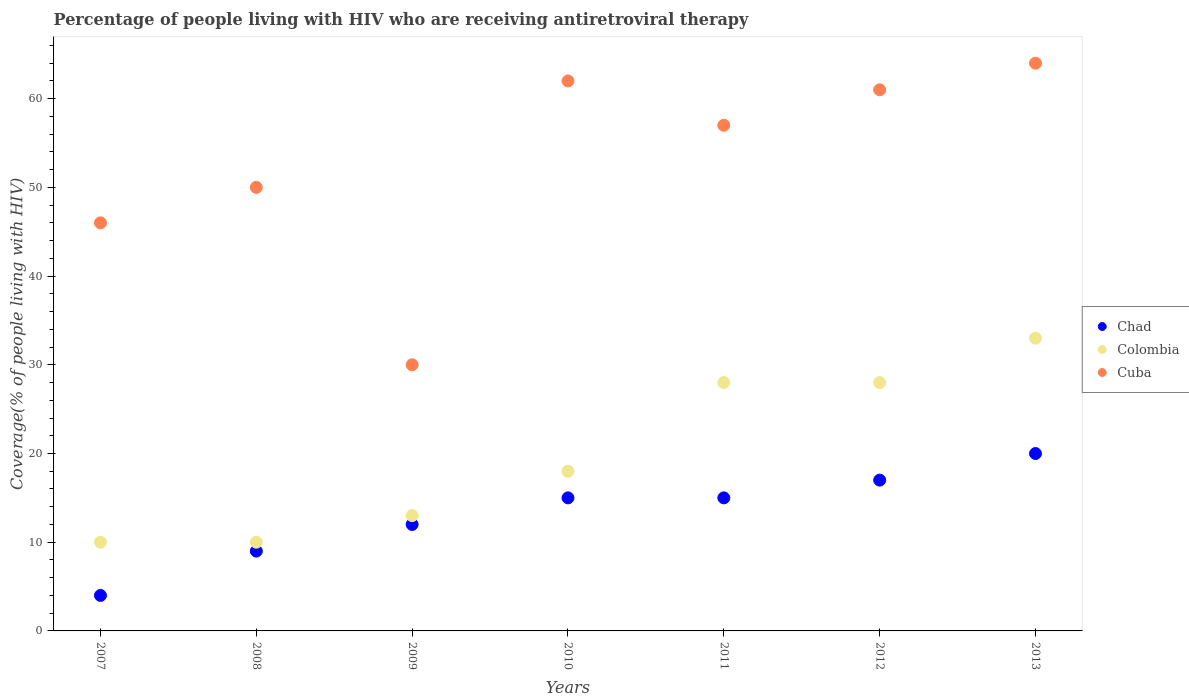How many different coloured dotlines are there?
Make the answer very short. 3. What is the percentage of the HIV infected people who are receiving antiretroviral therapy in Cuba in 2011?
Your response must be concise. 57. Across all years, what is the maximum percentage of the HIV infected people who are receiving antiretroviral therapy in Colombia?
Ensure brevity in your answer.  33. Across all years, what is the minimum percentage of the HIV infected people who are receiving antiretroviral therapy in Cuba?
Offer a terse response. 30. In which year was the percentage of the HIV infected people who are receiving antiretroviral therapy in Colombia maximum?
Keep it short and to the point. 2013. In which year was the percentage of the HIV infected people who are receiving antiretroviral therapy in Cuba minimum?
Provide a short and direct response. 2009. What is the total percentage of the HIV infected people who are receiving antiretroviral therapy in Cuba in the graph?
Provide a short and direct response. 370. What is the difference between the percentage of the HIV infected people who are receiving antiretroviral therapy in Chad in 2007 and that in 2012?
Offer a terse response. -13. What is the difference between the percentage of the HIV infected people who are receiving antiretroviral therapy in Chad in 2009 and the percentage of the HIV infected people who are receiving antiretroviral therapy in Colombia in 2007?
Your answer should be compact. 2. What is the average percentage of the HIV infected people who are receiving antiretroviral therapy in Chad per year?
Offer a terse response. 13.14. In the year 2011, what is the difference between the percentage of the HIV infected people who are receiving antiretroviral therapy in Colombia and percentage of the HIV infected people who are receiving antiretroviral therapy in Chad?
Make the answer very short. 13. What is the ratio of the percentage of the HIV infected people who are receiving antiretroviral therapy in Colombia in 2007 to that in 2012?
Provide a short and direct response. 0.36. Is the percentage of the HIV infected people who are receiving antiretroviral therapy in Chad in 2011 less than that in 2013?
Provide a short and direct response. Yes. What is the difference between the highest and the lowest percentage of the HIV infected people who are receiving antiretroviral therapy in Cuba?
Offer a terse response. 34. In how many years, is the percentage of the HIV infected people who are receiving antiretroviral therapy in Cuba greater than the average percentage of the HIV infected people who are receiving antiretroviral therapy in Cuba taken over all years?
Your answer should be compact. 4. Is it the case that in every year, the sum of the percentage of the HIV infected people who are receiving antiretroviral therapy in Chad and percentage of the HIV infected people who are receiving antiretroviral therapy in Colombia  is greater than the percentage of the HIV infected people who are receiving antiretroviral therapy in Cuba?
Provide a succinct answer. No. Is the percentage of the HIV infected people who are receiving antiretroviral therapy in Chad strictly greater than the percentage of the HIV infected people who are receiving antiretroviral therapy in Cuba over the years?
Keep it short and to the point. No. Is the percentage of the HIV infected people who are receiving antiretroviral therapy in Colombia strictly less than the percentage of the HIV infected people who are receiving antiretroviral therapy in Cuba over the years?
Offer a terse response. Yes. Does the graph contain grids?
Offer a terse response. No. Where does the legend appear in the graph?
Provide a short and direct response. Center right. How are the legend labels stacked?
Make the answer very short. Vertical. What is the title of the graph?
Provide a succinct answer. Percentage of people living with HIV who are receiving antiretroviral therapy. Does "Panama" appear as one of the legend labels in the graph?
Keep it short and to the point. No. What is the label or title of the X-axis?
Keep it short and to the point. Years. What is the label or title of the Y-axis?
Make the answer very short. Coverage(% of people living with HIV). What is the Coverage(% of people living with HIV) of Cuba in 2007?
Your answer should be compact. 46. What is the Coverage(% of people living with HIV) in Colombia in 2008?
Your answer should be compact. 10. What is the Coverage(% of people living with HIV) of Colombia in 2009?
Keep it short and to the point. 13. What is the Coverage(% of people living with HIV) in Cuba in 2009?
Your response must be concise. 30. What is the Coverage(% of people living with HIV) in Chad in 2010?
Your answer should be compact. 15. What is the Coverage(% of people living with HIV) in Cuba in 2010?
Offer a very short reply. 62. What is the Coverage(% of people living with HIV) of Chad in 2011?
Provide a short and direct response. 15. What is the Coverage(% of people living with HIV) in Colombia in 2011?
Ensure brevity in your answer.  28. What is the Coverage(% of people living with HIV) in Cuba in 2011?
Offer a very short reply. 57. What is the Coverage(% of people living with HIV) in Cuba in 2012?
Keep it short and to the point. 61. What is the Coverage(% of people living with HIV) of Chad in 2013?
Provide a short and direct response. 20. Across all years, what is the maximum Coverage(% of people living with HIV) in Chad?
Your answer should be compact. 20. Across all years, what is the minimum Coverage(% of people living with HIV) of Chad?
Provide a succinct answer. 4. Across all years, what is the minimum Coverage(% of people living with HIV) in Cuba?
Offer a very short reply. 30. What is the total Coverage(% of people living with HIV) of Chad in the graph?
Keep it short and to the point. 92. What is the total Coverage(% of people living with HIV) of Colombia in the graph?
Keep it short and to the point. 140. What is the total Coverage(% of people living with HIV) in Cuba in the graph?
Ensure brevity in your answer.  370. What is the difference between the Coverage(% of people living with HIV) in Chad in 2007 and that in 2008?
Ensure brevity in your answer.  -5. What is the difference between the Coverage(% of people living with HIV) of Colombia in 2007 and that in 2008?
Offer a terse response. 0. What is the difference between the Coverage(% of people living with HIV) in Cuba in 2007 and that in 2008?
Offer a terse response. -4. What is the difference between the Coverage(% of people living with HIV) in Colombia in 2007 and that in 2009?
Make the answer very short. -3. What is the difference between the Coverage(% of people living with HIV) in Cuba in 2007 and that in 2010?
Make the answer very short. -16. What is the difference between the Coverage(% of people living with HIV) in Colombia in 2007 and that in 2011?
Give a very brief answer. -18. What is the difference between the Coverage(% of people living with HIV) of Chad in 2007 and that in 2012?
Provide a succinct answer. -13. What is the difference between the Coverage(% of people living with HIV) of Cuba in 2007 and that in 2012?
Provide a short and direct response. -15. What is the difference between the Coverage(% of people living with HIV) of Chad in 2007 and that in 2013?
Give a very brief answer. -16. What is the difference between the Coverage(% of people living with HIV) of Chad in 2008 and that in 2009?
Offer a very short reply. -3. What is the difference between the Coverage(% of people living with HIV) of Chad in 2008 and that in 2010?
Ensure brevity in your answer.  -6. What is the difference between the Coverage(% of people living with HIV) in Chad in 2008 and that in 2011?
Make the answer very short. -6. What is the difference between the Coverage(% of people living with HIV) in Chad in 2008 and that in 2012?
Make the answer very short. -8. What is the difference between the Coverage(% of people living with HIV) in Colombia in 2008 and that in 2012?
Provide a succinct answer. -18. What is the difference between the Coverage(% of people living with HIV) in Cuba in 2008 and that in 2012?
Your answer should be very brief. -11. What is the difference between the Coverage(% of people living with HIV) of Colombia in 2008 and that in 2013?
Ensure brevity in your answer.  -23. What is the difference between the Coverage(% of people living with HIV) of Chad in 2009 and that in 2010?
Provide a succinct answer. -3. What is the difference between the Coverage(% of people living with HIV) in Cuba in 2009 and that in 2010?
Ensure brevity in your answer.  -32. What is the difference between the Coverage(% of people living with HIV) in Chad in 2009 and that in 2011?
Give a very brief answer. -3. What is the difference between the Coverage(% of people living with HIV) in Chad in 2009 and that in 2012?
Make the answer very short. -5. What is the difference between the Coverage(% of people living with HIV) of Cuba in 2009 and that in 2012?
Keep it short and to the point. -31. What is the difference between the Coverage(% of people living with HIV) in Chad in 2009 and that in 2013?
Ensure brevity in your answer.  -8. What is the difference between the Coverage(% of people living with HIV) in Cuba in 2009 and that in 2013?
Provide a succinct answer. -34. What is the difference between the Coverage(% of people living with HIV) of Chad in 2010 and that in 2011?
Offer a very short reply. 0. What is the difference between the Coverage(% of people living with HIV) of Cuba in 2010 and that in 2011?
Keep it short and to the point. 5. What is the difference between the Coverage(% of people living with HIV) of Chad in 2010 and that in 2012?
Ensure brevity in your answer.  -2. What is the difference between the Coverage(% of people living with HIV) in Colombia in 2010 and that in 2012?
Offer a terse response. -10. What is the difference between the Coverage(% of people living with HIV) in Chad in 2010 and that in 2013?
Ensure brevity in your answer.  -5. What is the difference between the Coverage(% of people living with HIV) of Colombia in 2010 and that in 2013?
Offer a terse response. -15. What is the difference between the Coverage(% of people living with HIV) of Cuba in 2010 and that in 2013?
Keep it short and to the point. -2. What is the difference between the Coverage(% of people living with HIV) of Cuba in 2011 and that in 2013?
Your response must be concise. -7. What is the difference between the Coverage(% of people living with HIV) in Chad in 2012 and that in 2013?
Offer a terse response. -3. What is the difference between the Coverage(% of people living with HIV) of Colombia in 2012 and that in 2013?
Provide a short and direct response. -5. What is the difference between the Coverage(% of people living with HIV) of Chad in 2007 and the Coverage(% of people living with HIV) of Cuba in 2008?
Ensure brevity in your answer.  -46. What is the difference between the Coverage(% of people living with HIV) of Colombia in 2007 and the Coverage(% of people living with HIV) of Cuba in 2008?
Ensure brevity in your answer.  -40. What is the difference between the Coverage(% of people living with HIV) in Colombia in 2007 and the Coverage(% of people living with HIV) in Cuba in 2009?
Provide a short and direct response. -20. What is the difference between the Coverage(% of people living with HIV) of Chad in 2007 and the Coverage(% of people living with HIV) of Cuba in 2010?
Give a very brief answer. -58. What is the difference between the Coverage(% of people living with HIV) of Colombia in 2007 and the Coverage(% of people living with HIV) of Cuba in 2010?
Your answer should be very brief. -52. What is the difference between the Coverage(% of people living with HIV) of Chad in 2007 and the Coverage(% of people living with HIV) of Cuba in 2011?
Your answer should be compact. -53. What is the difference between the Coverage(% of people living with HIV) of Colombia in 2007 and the Coverage(% of people living with HIV) of Cuba in 2011?
Give a very brief answer. -47. What is the difference between the Coverage(% of people living with HIV) of Chad in 2007 and the Coverage(% of people living with HIV) of Cuba in 2012?
Provide a short and direct response. -57. What is the difference between the Coverage(% of people living with HIV) in Colombia in 2007 and the Coverage(% of people living with HIV) in Cuba in 2012?
Offer a very short reply. -51. What is the difference between the Coverage(% of people living with HIV) in Chad in 2007 and the Coverage(% of people living with HIV) in Colombia in 2013?
Give a very brief answer. -29. What is the difference between the Coverage(% of people living with HIV) of Chad in 2007 and the Coverage(% of people living with HIV) of Cuba in 2013?
Provide a short and direct response. -60. What is the difference between the Coverage(% of people living with HIV) in Colombia in 2007 and the Coverage(% of people living with HIV) in Cuba in 2013?
Provide a succinct answer. -54. What is the difference between the Coverage(% of people living with HIV) in Chad in 2008 and the Coverage(% of people living with HIV) in Colombia in 2009?
Give a very brief answer. -4. What is the difference between the Coverage(% of people living with HIV) in Chad in 2008 and the Coverage(% of people living with HIV) in Cuba in 2009?
Give a very brief answer. -21. What is the difference between the Coverage(% of people living with HIV) of Colombia in 2008 and the Coverage(% of people living with HIV) of Cuba in 2009?
Ensure brevity in your answer.  -20. What is the difference between the Coverage(% of people living with HIV) of Chad in 2008 and the Coverage(% of people living with HIV) of Colombia in 2010?
Your answer should be compact. -9. What is the difference between the Coverage(% of people living with HIV) of Chad in 2008 and the Coverage(% of people living with HIV) of Cuba in 2010?
Offer a terse response. -53. What is the difference between the Coverage(% of people living with HIV) in Colombia in 2008 and the Coverage(% of people living with HIV) in Cuba in 2010?
Your answer should be compact. -52. What is the difference between the Coverage(% of people living with HIV) in Chad in 2008 and the Coverage(% of people living with HIV) in Colombia in 2011?
Provide a succinct answer. -19. What is the difference between the Coverage(% of people living with HIV) of Chad in 2008 and the Coverage(% of people living with HIV) of Cuba in 2011?
Your response must be concise. -48. What is the difference between the Coverage(% of people living with HIV) in Colombia in 2008 and the Coverage(% of people living with HIV) in Cuba in 2011?
Offer a very short reply. -47. What is the difference between the Coverage(% of people living with HIV) in Chad in 2008 and the Coverage(% of people living with HIV) in Colombia in 2012?
Give a very brief answer. -19. What is the difference between the Coverage(% of people living with HIV) in Chad in 2008 and the Coverage(% of people living with HIV) in Cuba in 2012?
Ensure brevity in your answer.  -52. What is the difference between the Coverage(% of people living with HIV) of Colombia in 2008 and the Coverage(% of people living with HIV) of Cuba in 2012?
Give a very brief answer. -51. What is the difference between the Coverage(% of people living with HIV) in Chad in 2008 and the Coverage(% of people living with HIV) in Cuba in 2013?
Provide a succinct answer. -55. What is the difference between the Coverage(% of people living with HIV) of Colombia in 2008 and the Coverage(% of people living with HIV) of Cuba in 2013?
Your answer should be compact. -54. What is the difference between the Coverage(% of people living with HIV) in Chad in 2009 and the Coverage(% of people living with HIV) in Cuba in 2010?
Offer a terse response. -50. What is the difference between the Coverage(% of people living with HIV) in Colombia in 2009 and the Coverage(% of people living with HIV) in Cuba in 2010?
Your answer should be very brief. -49. What is the difference between the Coverage(% of people living with HIV) in Chad in 2009 and the Coverage(% of people living with HIV) in Colombia in 2011?
Keep it short and to the point. -16. What is the difference between the Coverage(% of people living with HIV) of Chad in 2009 and the Coverage(% of people living with HIV) of Cuba in 2011?
Make the answer very short. -45. What is the difference between the Coverage(% of people living with HIV) in Colombia in 2009 and the Coverage(% of people living with HIV) in Cuba in 2011?
Offer a very short reply. -44. What is the difference between the Coverage(% of people living with HIV) in Chad in 2009 and the Coverage(% of people living with HIV) in Cuba in 2012?
Keep it short and to the point. -49. What is the difference between the Coverage(% of people living with HIV) of Colombia in 2009 and the Coverage(% of people living with HIV) of Cuba in 2012?
Make the answer very short. -48. What is the difference between the Coverage(% of people living with HIV) of Chad in 2009 and the Coverage(% of people living with HIV) of Colombia in 2013?
Keep it short and to the point. -21. What is the difference between the Coverage(% of people living with HIV) of Chad in 2009 and the Coverage(% of people living with HIV) of Cuba in 2013?
Your answer should be very brief. -52. What is the difference between the Coverage(% of people living with HIV) in Colombia in 2009 and the Coverage(% of people living with HIV) in Cuba in 2013?
Your response must be concise. -51. What is the difference between the Coverage(% of people living with HIV) of Chad in 2010 and the Coverage(% of people living with HIV) of Cuba in 2011?
Give a very brief answer. -42. What is the difference between the Coverage(% of people living with HIV) in Colombia in 2010 and the Coverage(% of people living with HIV) in Cuba in 2011?
Provide a succinct answer. -39. What is the difference between the Coverage(% of people living with HIV) of Chad in 2010 and the Coverage(% of people living with HIV) of Colombia in 2012?
Keep it short and to the point. -13. What is the difference between the Coverage(% of people living with HIV) of Chad in 2010 and the Coverage(% of people living with HIV) of Cuba in 2012?
Provide a short and direct response. -46. What is the difference between the Coverage(% of people living with HIV) in Colombia in 2010 and the Coverage(% of people living with HIV) in Cuba in 2012?
Your answer should be compact. -43. What is the difference between the Coverage(% of people living with HIV) in Chad in 2010 and the Coverage(% of people living with HIV) in Colombia in 2013?
Offer a very short reply. -18. What is the difference between the Coverage(% of people living with HIV) in Chad in 2010 and the Coverage(% of people living with HIV) in Cuba in 2013?
Offer a terse response. -49. What is the difference between the Coverage(% of people living with HIV) in Colombia in 2010 and the Coverage(% of people living with HIV) in Cuba in 2013?
Offer a very short reply. -46. What is the difference between the Coverage(% of people living with HIV) in Chad in 2011 and the Coverage(% of people living with HIV) in Colombia in 2012?
Offer a very short reply. -13. What is the difference between the Coverage(% of people living with HIV) of Chad in 2011 and the Coverage(% of people living with HIV) of Cuba in 2012?
Provide a succinct answer. -46. What is the difference between the Coverage(% of people living with HIV) in Colombia in 2011 and the Coverage(% of people living with HIV) in Cuba in 2012?
Your answer should be very brief. -33. What is the difference between the Coverage(% of people living with HIV) of Chad in 2011 and the Coverage(% of people living with HIV) of Cuba in 2013?
Offer a terse response. -49. What is the difference between the Coverage(% of people living with HIV) of Colombia in 2011 and the Coverage(% of people living with HIV) of Cuba in 2013?
Your answer should be compact. -36. What is the difference between the Coverage(% of people living with HIV) of Chad in 2012 and the Coverage(% of people living with HIV) of Colombia in 2013?
Provide a short and direct response. -16. What is the difference between the Coverage(% of people living with HIV) in Chad in 2012 and the Coverage(% of people living with HIV) in Cuba in 2013?
Your answer should be very brief. -47. What is the difference between the Coverage(% of people living with HIV) in Colombia in 2012 and the Coverage(% of people living with HIV) in Cuba in 2013?
Provide a short and direct response. -36. What is the average Coverage(% of people living with HIV) of Chad per year?
Your answer should be very brief. 13.14. What is the average Coverage(% of people living with HIV) in Colombia per year?
Make the answer very short. 20. What is the average Coverage(% of people living with HIV) of Cuba per year?
Your response must be concise. 52.86. In the year 2007, what is the difference between the Coverage(% of people living with HIV) of Chad and Coverage(% of people living with HIV) of Colombia?
Offer a terse response. -6. In the year 2007, what is the difference between the Coverage(% of people living with HIV) in Chad and Coverage(% of people living with HIV) in Cuba?
Your answer should be very brief. -42. In the year 2007, what is the difference between the Coverage(% of people living with HIV) in Colombia and Coverage(% of people living with HIV) in Cuba?
Provide a succinct answer. -36. In the year 2008, what is the difference between the Coverage(% of people living with HIV) in Chad and Coverage(% of people living with HIV) in Cuba?
Provide a short and direct response. -41. In the year 2009, what is the difference between the Coverage(% of people living with HIV) in Colombia and Coverage(% of people living with HIV) in Cuba?
Provide a short and direct response. -17. In the year 2010, what is the difference between the Coverage(% of people living with HIV) of Chad and Coverage(% of people living with HIV) of Cuba?
Provide a short and direct response. -47. In the year 2010, what is the difference between the Coverage(% of people living with HIV) in Colombia and Coverage(% of people living with HIV) in Cuba?
Your answer should be compact. -44. In the year 2011, what is the difference between the Coverage(% of people living with HIV) in Chad and Coverage(% of people living with HIV) in Cuba?
Provide a short and direct response. -42. In the year 2012, what is the difference between the Coverage(% of people living with HIV) in Chad and Coverage(% of people living with HIV) in Cuba?
Ensure brevity in your answer.  -44. In the year 2012, what is the difference between the Coverage(% of people living with HIV) of Colombia and Coverage(% of people living with HIV) of Cuba?
Your response must be concise. -33. In the year 2013, what is the difference between the Coverage(% of people living with HIV) in Chad and Coverage(% of people living with HIV) in Colombia?
Offer a very short reply. -13. In the year 2013, what is the difference between the Coverage(% of people living with HIV) in Chad and Coverage(% of people living with HIV) in Cuba?
Make the answer very short. -44. In the year 2013, what is the difference between the Coverage(% of people living with HIV) in Colombia and Coverage(% of people living with HIV) in Cuba?
Provide a succinct answer. -31. What is the ratio of the Coverage(% of people living with HIV) in Chad in 2007 to that in 2008?
Give a very brief answer. 0.44. What is the ratio of the Coverage(% of people living with HIV) in Chad in 2007 to that in 2009?
Your answer should be very brief. 0.33. What is the ratio of the Coverage(% of people living with HIV) of Colombia in 2007 to that in 2009?
Your answer should be very brief. 0.77. What is the ratio of the Coverage(% of people living with HIV) of Cuba in 2007 to that in 2009?
Keep it short and to the point. 1.53. What is the ratio of the Coverage(% of people living with HIV) of Chad in 2007 to that in 2010?
Give a very brief answer. 0.27. What is the ratio of the Coverage(% of people living with HIV) of Colombia in 2007 to that in 2010?
Your answer should be compact. 0.56. What is the ratio of the Coverage(% of people living with HIV) of Cuba in 2007 to that in 2010?
Provide a short and direct response. 0.74. What is the ratio of the Coverage(% of people living with HIV) of Chad in 2007 to that in 2011?
Make the answer very short. 0.27. What is the ratio of the Coverage(% of people living with HIV) in Colombia in 2007 to that in 2011?
Give a very brief answer. 0.36. What is the ratio of the Coverage(% of people living with HIV) of Cuba in 2007 to that in 2011?
Make the answer very short. 0.81. What is the ratio of the Coverage(% of people living with HIV) in Chad in 2007 to that in 2012?
Make the answer very short. 0.24. What is the ratio of the Coverage(% of people living with HIV) of Colombia in 2007 to that in 2012?
Offer a very short reply. 0.36. What is the ratio of the Coverage(% of people living with HIV) of Cuba in 2007 to that in 2012?
Keep it short and to the point. 0.75. What is the ratio of the Coverage(% of people living with HIV) of Colombia in 2007 to that in 2013?
Offer a terse response. 0.3. What is the ratio of the Coverage(% of people living with HIV) of Cuba in 2007 to that in 2013?
Offer a terse response. 0.72. What is the ratio of the Coverage(% of people living with HIV) of Colombia in 2008 to that in 2009?
Offer a terse response. 0.77. What is the ratio of the Coverage(% of people living with HIV) of Colombia in 2008 to that in 2010?
Make the answer very short. 0.56. What is the ratio of the Coverage(% of people living with HIV) of Cuba in 2008 to that in 2010?
Give a very brief answer. 0.81. What is the ratio of the Coverage(% of people living with HIV) in Colombia in 2008 to that in 2011?
Provide a short and direct response. 0.36. What is the ratio of the Coverage(% of people living with HIV) of Cuba in 2008 to that in 2011?
Offer a terse response. 0.88. What is the ratio of the Coverage(% of people living with HIV) of Chad in 2008 to that in 2012?
Offer a very short reply. 0.53. What is the ratio of the Coverage(% of people living with HIV) of Colombia in 2008 to that in 2012?
Offer a very short reply. 0.36. What is the ratio of the Coverage(% of people living with HIV) of Cuba in 2008 to that in 2012?
Keep it short and to the point. 0.82. What is the ratio of the Coverage(% of people living with HIV) of Chad in 2008 to that in 2013?
Provide a succinct answer. 0.45. What is the ratio of the Coverage(% of people living with HIV) in Colombia in 2008 to that in 2013?
Provide a succinct answer. 0.3. What is the ratio of the Coverage(% of people living with HIV) of Cuba in 2008 to that in 2013?
Make the answer very short. 0.78. What is the ratio of the Coverage(% of people living with HIV) in Colombia in 2009 to that in 2010?
Provide a succinct answer. 0.72. What is the ratio of the Coverage(% of people living with HIV) of Cuba in 2009 to that in 2010?
Give a very brief answer. 0.48. What is the ratio of the Coverage(% of people living with HIV) of Chad in 2009 to that in 2011?
Keep it short and to the point. 0.8. What is the ratio of the Coverage(% of people living with HIV) of Colombia in 2009 to that in 2011?
Your answer should be compact. 0.46. What is the ratio of the Coverage(% of people living with HIV) in Cuba in 2009 to that in 2011?
Give a very brief answer. 0.53. What is the ratio of the Coverage(% of people living with HIV) of Chad in 2009 to that in 2012?
Your answer should be very brief. 0.71. What is the ratio of the Coverage(% of people living with HIV) of Colombia in 2009 to that in 2012?
Ensure brevity in your answer.  0.46. What is the ratio of the Coverage(% of people living with HIV) of Cuba in 2009 to that in 2012?
Provide a succinct answer. 0.49. What is the ratio of the Coverage(% of people living with HIV) of Colombia in 2009 to that in 2013?
Offer a very short reply. 0.39. What is the ratio of the Coverage(% of people living with HIV) in Cuba in 2009 to that in 2013?
Provide a short and direct response. 0.47. What is the ratio of the Coverage(% of people living with HIV) in Colombia in 2010 to that in 2011?
Offer a terse response. 0.64. What is the ratio of the Coverage(% of people living with HIV) in Cuba in 2010 to that in 2011?
Keep it short and to the point. 1.09. What is the ratio of the Coverage(% of people living with HIV) in Chad in 2010 to that in 2012?
Provide a succinct answer. 0.88. What is the ratio of the Coverage(% of people living with HIV) in Colombia in 2010 to that in 2012?
Offer a very short reply. 0.64. What is the ratio of the Coverage(% of people living with HIV) in Cuba in 2010 to that in 2012?
Your answer should be very brief. 1.02. What is the ratio of the Coverage(% of people living with HIV) of Chad in 2010 to that in 2013?
Your answer should be compact. 0.75. What is the ratio of the Coverage(% of people living with HIV) in Colombia in 2010 to that in 2013?
Your response must be concise. 0.55. What is the ratio of the Coverage(% of people living with HIV) in Cuba in 2010 to that in 2013?
Your answer should be compact. 0.97. What is the ratio of the Coverage(% of people living with HIV) in Chad in 2011 to that in 2012?
Your answer should be very brief. 0.88. What is the ratio of the Coverage(% of people living with HIV) in Colombia in 2011 to that in 2012?
Provide a short and direct response. 1. What is the ratio of the Coverage(% of people living with HIV) of Cuba in 2011 to that in 2012?
Offer a terse response. 0.93. What is the ratio of the Coverage(% of people living with HIV) of Chad in 2011 to that in 2013?
Offer a terse response. 0.75. What is the ratio of the Coverage(% of people living with HIV) of Colombia in 2011 to that in 2013?
Provide a succinct answer. 0.85. What is the ratio of the Coverage(% of people living with HIV) in Cuba in 2011 to that in 2013?
Ensure brevity in your answer.  0.89. What is the ratio of the Coverage(% of people living with HIV) in Chad in 2012 to that in 2013?
Your answer should be compact. 0.85. What is the ratio of the Coverage(% of people living with HIV) of Colombia in 2012 to that in 2013?
Give a very brief answer. 0.85. What is the ratio of the Coverage(% of people living with HIV) of Cuba in 2012 to that in 2013?
Make the answer very short. 0.95. What is the difference between the highest and the second highest Coverage(% of people living with HIV) in Colombia?
Give a very brief answer. 5. What is the difference between the highest and the lowest Coverage(% of people living with HIV) in Cuba?
Your answer should be compact. 34. 